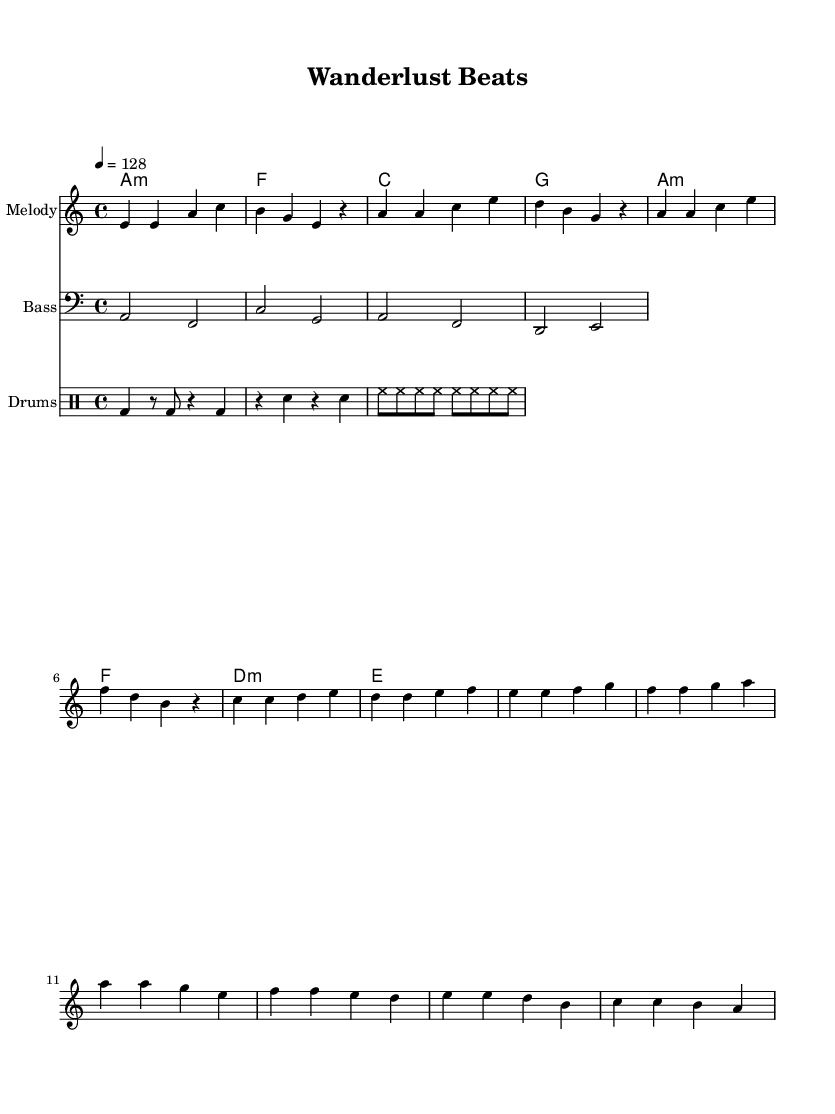What is the key signature of this music? The key signature is A minor, which has no sharps or flats.
Answer: A minor What is the time signature of this music? The time signature is indicated by the numbers at the beginning of the score, which is 4 over 4.
Answer: 4/4 What is the tempo marking in this music? The tempo marking specifies a speed of 128 beats per minute, shown as "4 = 128".
Answer: 128 How many measures are in the chorus section? Counting the measures in the chorus reveals there are four distinct measures comprising the chorus itself.
Answer: 4 Which chord appears most frequently in the harmonies? Analyzing the chord progression, the A minor chord appears twice within the eight bars of harmonies provided.
Answer: A minor What is the predominant instrumentation used in this piece? The score indicates three distinct layers of sound: melody, bass, and drums, which are standard for dance tracks.
Answer: Melody, Bass, Drums How does the rhythm for the drums create a danceable groove? The drum section uses a combination of bass and snare drum hits across the measures, creating a syncopated rhythm characteristic of dance music.
Answer: Syncopated rhythm 